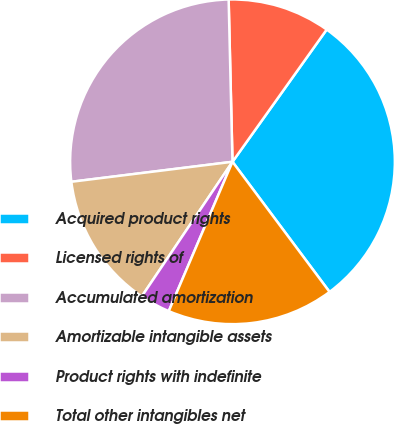<chart> <loc_0><loc_0><loc_500><loc_500><pie_chart><fcel>Acquired product rights<fcel>Licensed rights of<fcel>Accumulated amortization<fcel>Amortizable intangible assets<fcel>Product rights with indefinite<fcel>Total other intangibles net<nl><fcel>29.95%<fcel>10.23%<fcel>26.59%<fcel>13.6%<fcel>3.02%<fcel>16.62%<nl></chart> 